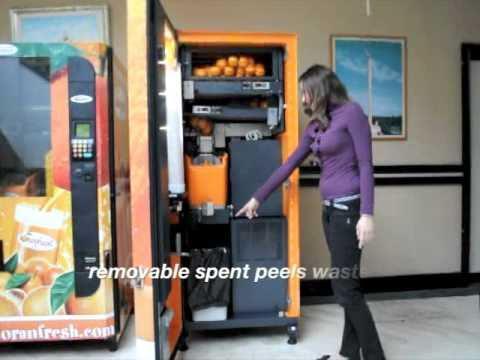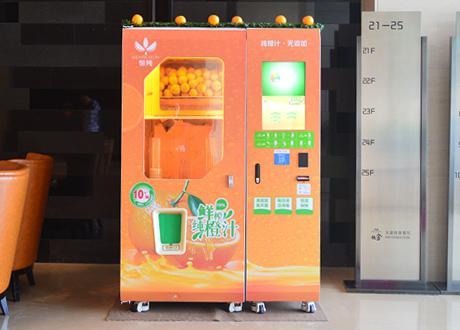The first image is the image on the left, the second image is the image on the right. Given the left and right images, does the statement "A human is standing next to a vending machine in one of the images." hold true? Answer yes or no. Yes. The first image is the image on the left, the second image is the image on the right. Evaluate the accuracy of this statement regarding the images: "Real oranges are visible in the top half of all the vending machines, which also feature orange as a major part of their color schemes.". Is it true? Answer yes or no. Yes. 